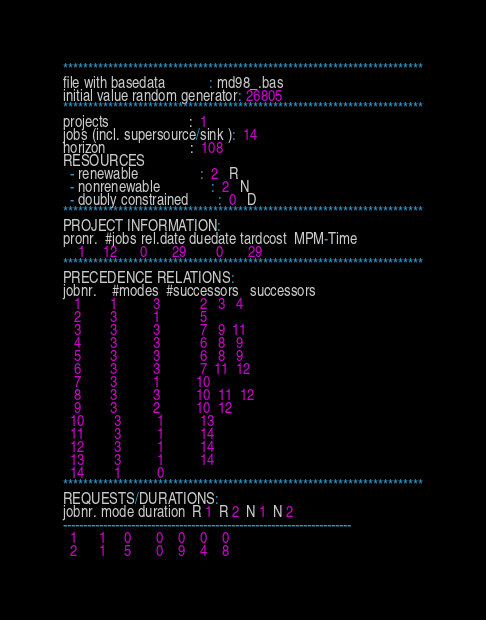<code> <loc_0><loc_0><loc_500><loc_500><_ObjectiveC_>************************************************************************
file with basedata            : md98_.bas
initial value random generator: 26805
************************************************************************
projects                      :  1
jobs (incl. supersource/sink ):  14
horizon                       :  108
RESOURCES
  - renewable                 :  2   R
  - nonrenewable              :  2   N
  - doubly constrained        :  0   D
************************************************************************
PROJECT INFORMATION:
pronr.  #jobs rel.date duedate tardcost  MPM-Time
    1     12      0       29        0       29
************************************************************************
PRECEDENCE RELATIONS:
jobnr.    #modes  #successors   successors
   1        1          3           2   3   4
   2        3          1           5
   3        3          3           7   9  11
   4        3          3           6   8   9
   5        3          3           6   8   9
   6        3          3           7  11  12
   7        3          1          10
   8        3          3          10  11  12
   9        3          2          10  12
  10        3          1          13
  11        3          1          14
  12        3          1          14
  13        3          1          14
  14        1          0        
************************************************************************
REQUESTS/DURATIONS:
jobnr. mode duration  R 1  R 2  N 1  N 2
------------------------------------------------------------------------
  1      1     0       0    0    0    0
  2      1     5       0    9    4    8</code> 